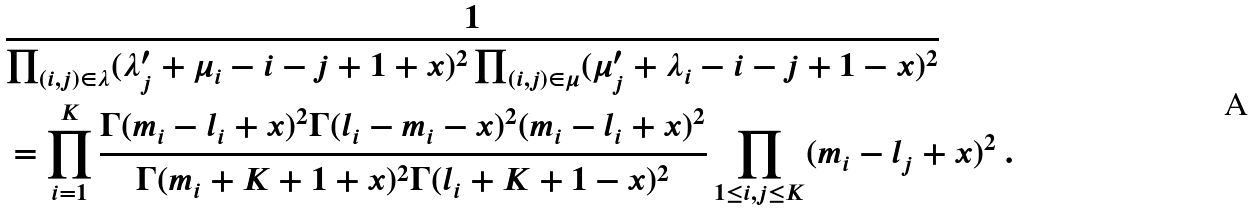Convert formula to latex. <formula><loc_0><loc_0><loc_500><loc_500>& \frac { 1 } { \prod _ { ( i , j ) \in \lambda } ( \lambda ^ { \prime } _ { j } + \mu _ { i } - i - j + 1 + x ) ^ { 2 } \prod _ { ( i , j ) \in \mu } ( \mu ^ { \prime } _ { j } + \lambda _ { i } - i - j + 1 - x ) ^ { 2 } } \\ & = \prod _ { i = 1 } ^ { K } \frac { \Gamma ( m _ { i } - l _ { i } + x ) ^ { 2 } \Gamma ( l _ { i } - m _ { i } - x ) ^ { 2 } ( m _ { i } - l _ { i } + x ) ^ { 2 } } { \Gamma ( m _ { i } + K + 1 + x ) ^ { 2 } \Gamma ( l _ { i } + K + 1 - x ) ^ { 2 } } \prod _ { 1 \leq i , j \leq K } ( m _ { i } - l _ { j } + x ) ^ { 2 } \ .</formula> 